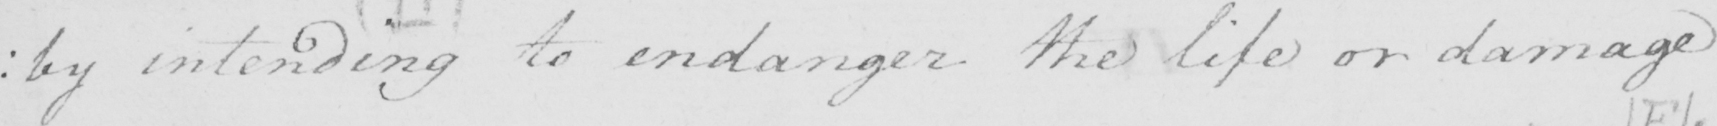Transcribe the text shown in this historical manuscript line. : by intending to endanger the life or damage 